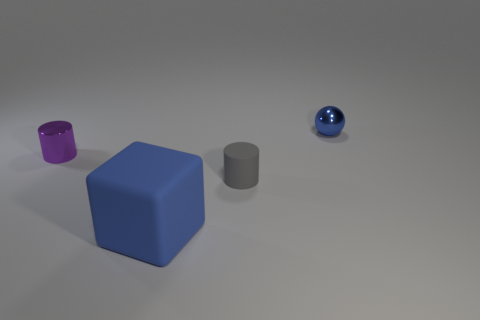The tiny thing in front of the purple cylinder has what shape?
Give a very brief answer. Cylinder. Does the small gray object have the same material as the thing in front of the gray matte cylinder?
Provide a succinct answer. Yes. Are there any small gray rubber things?
Offer a terse response. Yes. Are there any shiny cylinders that are on the right side of the tiny gray cylinder in front of the object to the right of the gray thing?
Offer a very short reply. No. How many small objects are either blue cubes or yellow matte objects?
Offer a terse response. 0. There is a cylinder that is the same size as the gray thing; what is its color?
Provide a succinct answer. Purple. What number of things are left of the big matte block?
Your response must be concise. 1. Are there any small blue balls that have the same material as the tiny purple cylinder?
Offer a very short reply. Yes. The metal thing that is the same color as the large cube is what shape?
Your response must be concise. Sphere. What is the color of the shiny thing on the right side of the purple shiny object?
Your answer should be compact. Blue. 